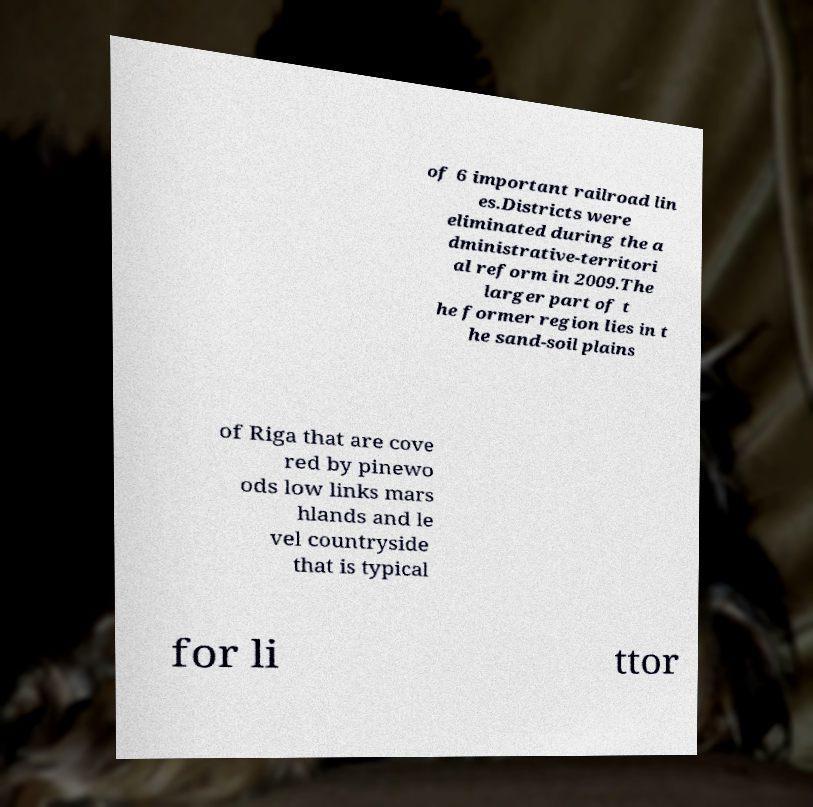What messages or text are displayed in this image? I need them in a readable, typed format. of 6 important railroad lin es.Districts were eliminated during the a dministrative-territori al reform in 2009.The larger part of t he former region lies in t he sand-soil plains of Riga that are cove red by pinewo ods low links mars hlands and le vel countryside that is typical for li ttor 